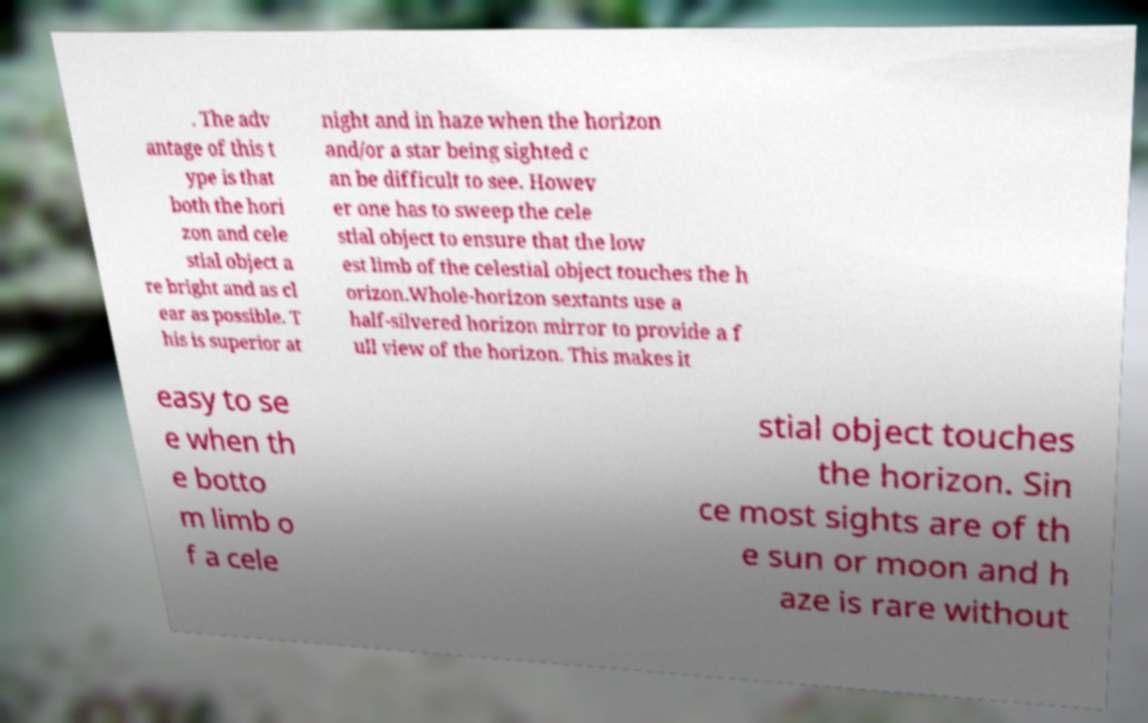Can you read and provide the text displayed in the image?This photo seems to have some interesting text. Can you extract and type it out for me? . The adv antage of this t ype is that both the hori zon and cele stial object a re bright and as cl ear as possible. T his is superior at night and in haze when the horizon and/or a star being sighted c an be difficult to see. Howev er one has to sweep the cele stial object to ensure that the low est limb of the celestial object touches the h orizon.Whole-horizon sextants use a half-silvered horizon mirror to provide a f ull view of the horizon. This makes it easy to se e when th e botto m limb o f a cele stial object touches the horizon. Sin ce most sights are of th e sun or moon and h aze is rare without 